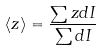<formula> <loc_0><loc_0><loc_500><loc_500>\langle z \rangle = \frac { \sum z d I } { \sum d I }</formula> 